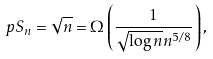<formula> <loc_0><loc_0><loc_500><loc_500>\ p { S _ { n } = \sqrt { n } } = \Omega \left ( \frac { 1 } { \sqrt { \log n } n ^ { 5 / 8 } } \right ) ,</formula> 